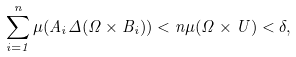<formula> <loc_0><loc_0><loc_500><loc_500>\sum _ { i = 1 } ^ { n } \mu ( A _ { i } \Delta ( \Omega \times B _ { i } ) ) < n \mu ( \Omega \times U ) < \delta ,</formula> 